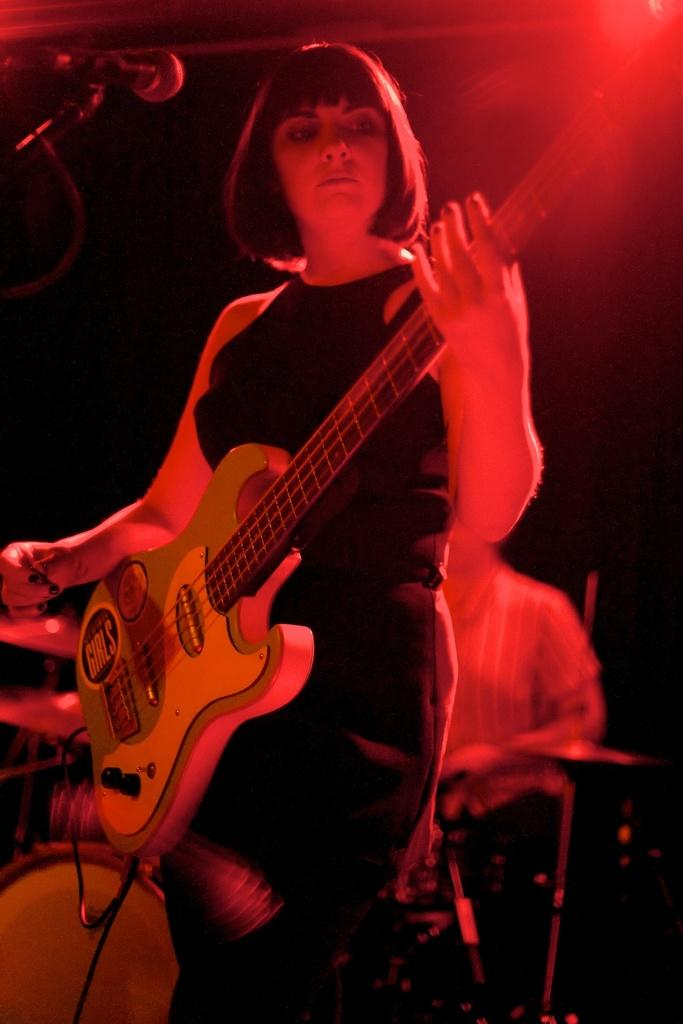Who is present in the image? There is a woman in the image. What is the woman holding? The woman is holding a guitar. What is the man in the image doing? The man is sitting in the image. What else can be seen in the image besides the people? There are musical instruments and a light in the image. What type of pencil is the woman using to play the guitar in the image? There is no pencil present in the image, and the woman is not using a pencil to play the guitar. 